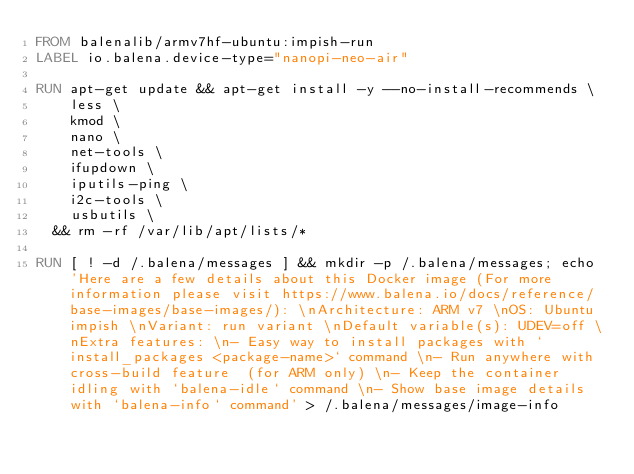Convert code to text. <code><loc_0><loc_0><loc_500><loc_500><_Dockerfile_>FROM balenalib/armv7hf-ubuntu:impish-run
LABEL io.balena.device-type="nanopi-neo-air"

RUN apt-get update && apt-get install -y --no-install-recommends \
		less \
		kmod \
		nano \
		net-tools \
		ifupdown \
		iputils-ping \
		i2c-tools \
		usbutils \
	&& rm -rf /var/lib/apt/lists/*

RUN [ ! -d /.balena/messages ] && mkdir -p /.balena/messages; echo 'Here are a few details about this Docker image (For more information please visit https://www.balena.io/docs/reference/base-images/base-images/): \nArchitecture: ARM v7 \nOS: Ubuntu impish \nVariant: run variant \nDefault variable(s): UDEV=off \nExtra features: \n- Easy way to install packages with `install_packages <package-name>` command \n- Run anywhere with cross-build feature  (for ARM only) \n- Keep the container idling with `balena-idle` command \n- Show base image details with `balena-info` command' > /.balena/messages/image-info</code> 